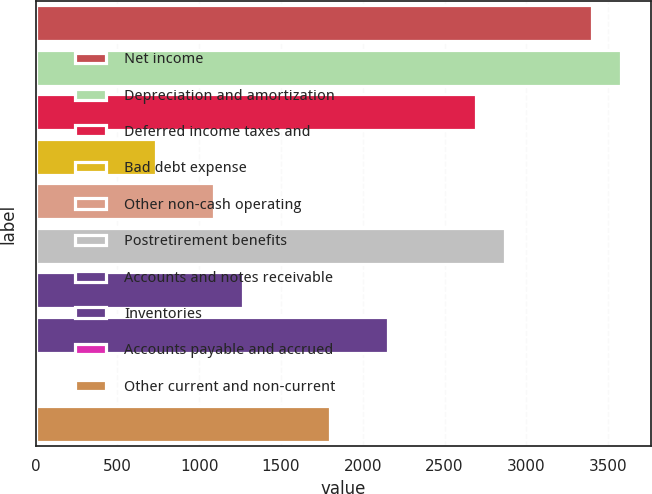<chart> <loc_0><loc_0><loc_500><loc_500><bar_chart><fcel>Net income<fcel>Depreciation and amortization<fcel>Deferred income taxes and<fcel>Bad debt expense<fcel>Other non-cash operating<fcel>Postretirement benefits<fcel>Accounts and notes receivable<fcel>Inventories<fcel>Accounts payable and accrued<fcel>Other current and non-current<nl><fcel>3402.1<fcel>3580<fcel>2690.5<fcel>733.6<fcel>1089.4<fcel>2868.4<fcel>1267.3<fcel>2156.8<fcel>22<fcel>1801<nl></chart> 